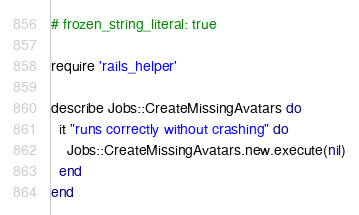Convert code to text. <code><loc_0><loc_0><loc_500><loc_500><_Ruby_># frozen_string_literal: true

require 'rails_helper'

describe Jobs::CreateMissingAvatars do
  it "runs correctly without crashing" do
    Jobs::CreateMissingAvatars.new.execute(nil)
  end
end
</code> 